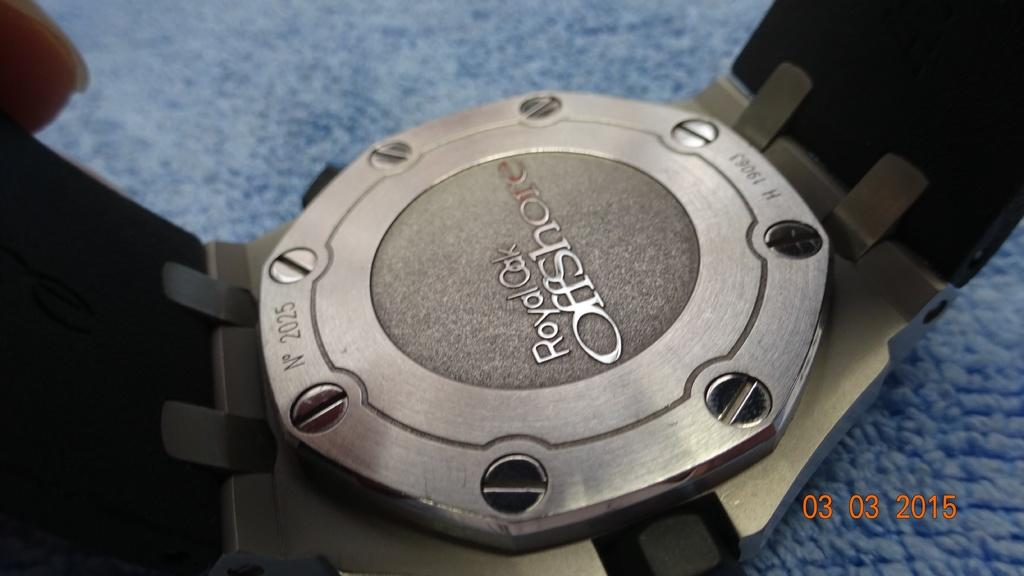<image>
Create a compact narrative representing the image presented. A watch with serial number 2025, is lying face down on a blue surface. 